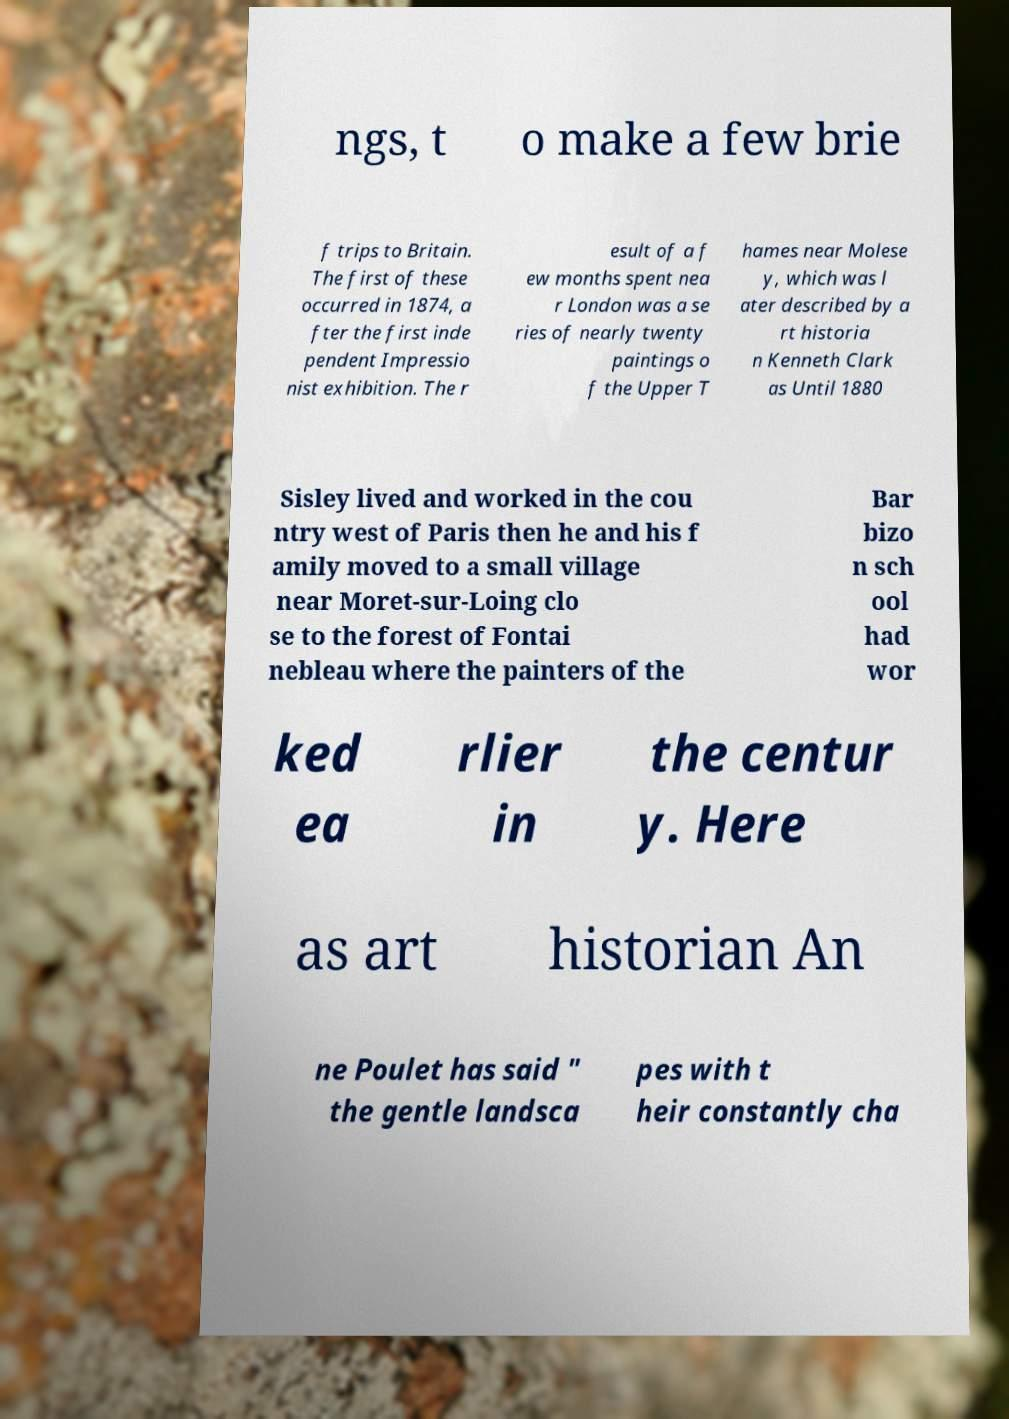Could you assist in decoding the text presented in this image and type it out clearly? ngs, t o make a few brie f trips to Britain. The first of these occurred in 1874, a fter the first inde pendent Impressio nist exhibition. The r esult of a f ew months spent nea r London was a se ries of nearly twenty paintings o f the Upper T hames near Molese y, which was l ater described by a rt historia n Kenneth Clark as Until 1880 Sisley lived and worked in the cou ntry west of Paris then he and his f amily moved to a small village near Moret-sur-Loing clo se to the forest of Fontai nebleau where the painters of the Bar bizo n sch ool had wor ked ea rlier in the centur y. Here as art historian An ne Poulet has said " the gentle landsca pes with t heir constantly cha 